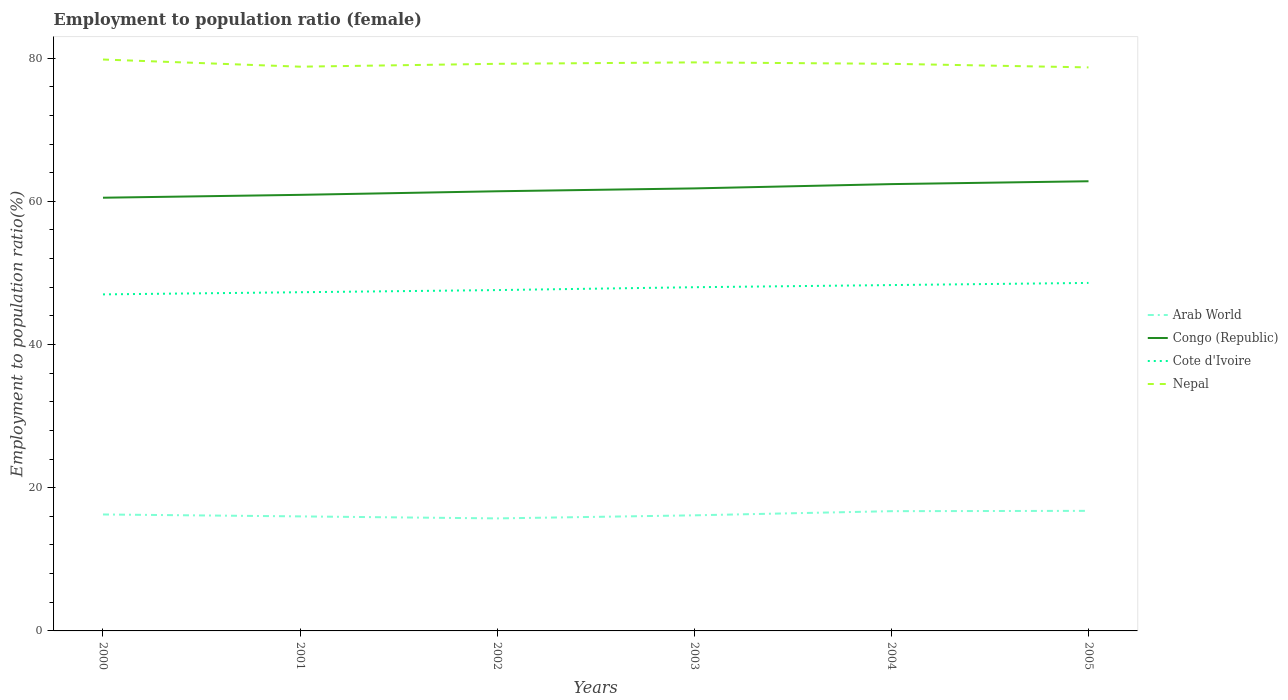How many different coloured lines are there?
Ensure brevity in your answer.  4. Is the number of lines equal to the number of legend labels?
Keep it short and to the point. Yes. In which year was the employment to population ratio in Nepal maximum?
Your answer should be very brief. 2005. What is the total employment to population ratio in Congo (Republic) in the graph?
Your answer should be compact. -1.9. What is the difference between the highest and the second highest employment to population ratio in Congo (Republic)?
Offer a terse response. 2.3. Is the employment to population ratio in Arab World strictly greater than the employment to population ratio in Nepal over the years?
Make the answer very short. Yes. How many years are there in the graph?
Your answer should be very brief. 6. Does the graph contain any zero values?
Make the answer very short. No. How many legend labels are there?
Your answer should be very brief. 4. How are the legend labels stacked?
Make the answer very short. Vertical. What is the title of the graph?
Keep it short and to the point. Employment to population ratio (female). What is the label or title of the X-axis?
Give a very brief answer. Years. What is the Employment to population ratio(%) in Arab World in 2000?
Provide a short and direct response. 16.26. What is the Employment to population ratio(%) in Congo (Republic) in 2000?
Offer a very short reply. 60.5. What is the Employment to population ratio(%) in Nepal in 2000?
Give a very brief answer. 79.8. What is the Employment to population ratio(%) in Arab World in 2001?
Your answer should be compact. 16. What is the Employment to population ratio(%) of Congo (Republic) in 2001?
Provide a short and direct response. 60.9. What is the Employment to population ratio(%) of Cote d'Ivoire in 2001?
Offer a very short reply. 47.3. What is the Employment to population ratio(%) of Nepal in 2001?
Offer a terse response. 78.8. What is the Employment to population ratio(%) of Arab World in 2002?
Ensure brevity in your answer.  15.71. What is the Employment to population ratio(%) of Congo (Republic) in 2002?
Make the answer very short. 61.4. What is the Employment to population ratio(%) in Cote d'Ivoire in 2002?
Your response must be concise. 47.6. What is the Employment to population ratio(%) in Nepal in 2002?
Give a very brief answer. 79.2. What is the Employment to population ratio(%) of Arab World in 2003?
Your answer should be compact. 16.14. What is the Employment to population ratio(%) in Congo (Republic) in 2003?
Your answer should be compact. 61.8. What is the Employment to population ratio(%) of Nepal in 2003?
Provide a short and direct response. 79.4. What is the Employment to population ratio(%) in Arab World in 2004?
Keep it short and to the point. 16.72. What is the Employment to population ratio(%) of Congo (Republic) in 2004?
Provide a succinct answer. 62.4. What is the Employment to population ratio(%) in Cote d'Ivoire in 2004?
Your response must be concise. 48.3. What is the Employment to population ratio(%) of Nepal in 2004?
Provide a short and direct response. 79.2. What is the Employment to population ratio(%) in Arab World in 2005?
Your response must be concise. 16.77. What is the Employment to population ratio(%) in Congo (Republic) in 2005?
Keep it short and to the point. 62.8. What is the Employment to population ratio(%) of Cote d'Ivoire in 2005?
Offer a terse response. 48.6. What is the Employment to population ratio(%) of Nepal in 2005?
Make the answer very short. 78.7. Across all years, what is the maximum Employment to population ratio(%) in Arab World?
Your answer should be very brief. 16.77. Across all years, what is the maximum Employment to population ratio(%) of Congo (Republic)?
Ensure brevity in your answer.  62.8. Across all years, what is the maximum Employment to population ratio(%) in Cote d'Ivoire?
Ensure brevity in your answer.  48.6. Across all years, what is the maximum Employment to population ratio(%) in Nepal?
Provide a short and direct response. 79.8. Across all years, what is the minimum Employment to population ratio(%) of Arab World?
Make the answer very short. 15.71. Across all years, what is the minimum Employment to population ratio(%) in Congo (Republic)?
Your answer should be compact. 60.5. Across all years, what is the minimum Employment to population ratio(%) in Nepal?
Keep it short and to the point. 78.7. What is the total Employment to population ratio(%) in Arab World in the graph?
Make the answer very short. 97.61. What is the total Employment to population ratio(%) in Congo (Republic) in the graph?
Give a very brief answer. 369.8. What is the total Employment to population ratio(%) in Cote d'Ivoire in the graph?
Offer a very short reply. 286.8. What is the total Employment to population ratio(%) in Nepal in the graph?
Your answer should be compact. 475.1. What is the difference between the Employment to population ratio(%) of Arab World in 2000 and that in 2001?
Your response must be concise. 0.27. What is the difference between the Employment to population ratio(%) in Nepal in 2000 and that in 2001?
Give a very brief answer. 1. What is the difference between the Employment to population ratio(%) in Arab World in 2000 and that in 2002?
Your answer should be compact. 0.55. What is the difference between the Employment to population ratio(%) of Cote d'Ivoire in 2000 and that in 2002?
Provide a short and direct response. -0.6. What is the difference between the Employment to population ratio(%) in Nepal in 2000 and that in 2002?
Offer a very short reply. 0.6. What is the difference between the Employment to population ratio(%) in Arab World in 2000 and that in 2003?
Your answer should be compact. 0.12. What is the difference between the Employment to population ratio(%) in Congo (Republic) in 2000 and that in 2003?
Provide a succinct answer. -1.3. What is the difference between the Employment to population ratio(%) of Nepal in 2000 and that in 2003?
Your answer should be very brief. 0.4. What is the difference between the Employment to population ratio(%) of Arab World in 2000 and that in 2004?
Offer a terse response. -0.46. What is the difference between the Employment to population ratio(%) of Congo (Republic) in 2000 and that in 2004?
Offer a very short reply. -1.9. What is the difference between the Employment to population ratio(%) in Arab World in 2000 and that in 2005?
Your answer should be compact. -0.5. What is the difference between the Employment to population ratio(%) in Congo (Republic) in 2000 and that in 2005?
Provide a short and direct response. -2.3. What is the difference between the Employment to population ratio(%) in Nepal in 2000 and that in 2005?
Offer a very short reply. 1.1. What is the difference between the Employment to population ratio(%) of Arab World in 2001 and that in 2002?
Your answer should be compact. 0.28. What is the difference between the Employment to population ratio(%) of Congo (Republic) in 2001 and that in 2002?
Keep it short and to the point. -0.5. What is the difference between the Employment to population ratio(%) in Cote d'Ivoire in 2001 and that in 2002?
Your answer should be compact. -0.3. What is the difference between the Employment to population ratio(%) in Nepal in 2001 and that in 2002?
Your response must be concise. -0.4. What is the difference between the Employment to population ratio(%) in Arab World in 2001 and that in 2003?
Your answer should be compact. -0.15. What is the difference between the Employment to population ratio(%) of Arab World in 2001 and that in 2004?
Provide a succinct answer. -0.73. What is the difference between the Employment to population ratio(%) in Arab World in 2001 and that in 2005?
Provide a short and direct response. -0.77. What is the difference between the Employment to population ratio(%) in Cote d'Ivoire in 2001 and that in 2005?
Make the answer very short. -1.3. What is the difference between the Employment to population ratio(%) of Nepal in 2001 and that in 2005?
Your response must be concise. 0.1. What is the difference between the Employment to population ratio(%) in Arab World in 2002 and that in 2003?
Offer a terse response. -0.43. What is the difference between the Employment to population ratio(%) of Congo (Republic) in 2002 and that in 2003?
Make the answer very short. -0.4. What is the difference between the Employment to population ratio(%) of Nepal in 2002 and that in 2003?
Keep it short and to the point. -0.2. What is the difference between the Employment to population ratio(%) in Arab World in 2002 and that in 2004?
Provide a short and direct response. -1.01. What is the difference between the Employment to population ratio(%) of Congo (Republic) in 2002 and that in 2004?
Your answer should be compact. -1. What is the difference between the Employment to population ratio(%) of Cote d'Ivoire in 2002 and that in 2004?
Ensure brevity in your answer.  -0.7. What is the difference between the Employment to population ratio(%) in Nepal in 2002 and that in 2004?
Keep it short and to the point. 0. What is the difference between the Employment to population ratio(%) of Arab World in 2002 and that in 2005?
Ensure brevity in your answer.  -1.05. What is the difference between the Employment to population ratio(%) in Arab World in 2003 and that in 2004?
Keep it short and to the point. -0.58. What is the difference between the Employment to population ratio(%) in Congo (Republic) in 2003 and that in 2004?
Your response must be concise. -0.6. What is the difference between the Employment to population ratio(%) of Arab World in 2003 and that in 2005?
Your answer should be compact. -0.62. What is the difference between the Employment to population ratio(%) of Congo (Republic) in 2003 and that in 2005?
Provide a succinct answer. -1. What is the difference between the Employment to population ratio(%) of Cote d'Ivoire in 2003 and that in 2005?
Your answer should be very brief. -0.6. What is the difference between the Employment to population ratio(%) in Arab World in 2004 and that in 2005?
Ensure brevity in your answer.  -0.04. What is the difference between the Employment to population ratio(%) in Cote d'Ivoire in 2004 and that in 2005?
Provide a succinct answer. -0.3. What is the difference between the Employment to population ratio(%) of Arab World in 2000 and the Employment to population ratio(%) of Congo (Republic) in 2001?
Your answer should be compact. -44.64. What is the difference between the Employment to population ratio(%) of Arab World in 2000 and the Employment to population ratio(%) of Cote d'Ivoire in 2001?
Offer a very short reply. -31.04. What is the difference between the Employment to population ratio(%) in Arab World in 2000 and the Employment to population ratio(%) in Nepal in 2001?
Make the answer very short. -62.54. What is the difference between the Employment to population ratio(%) of Congo (Republic) in 2000 and the Employment to population ratio(%) of Nepal in 2001?
Give a very brief answer. -18.3. What is the difference between the Employment to population ratio(%) of Cote d'Ivoire in 2000 and the Employment to population ratio(%) of Nepal in 2001?
Provide a succinct answer. -31.8. What is the difference between the Employment to population ratio(%) in Arab World in 2000 and the Employment to population ratio(%) in Congo (Republic) in 2002?
Make the answer very short. -45.14. What is the difference between the Employment to population ratio(%) of Arab World in 2000 and the Employment to population ratio(%) of Cote d'Ivoire in 2002?
Your answer should be compact. -31.34. What is the difference between the Employment to population ratio(%) in Arab World in 2000 and the Employment to population ratio(%) in Nepal in 2002?
Make the answer very short. -62.94. What is the difference between the Employment to population ratio(%) in Congo (Republic) in 2000 and the Employment to population ratio(%) in Nepal in 2002?
Offer a terse response. -18.7. What is the difference between the Employment to population ratio(%) of Cote d'Ivoire in 2000 and the Employment to population ratio(%) of Nepal in 2002?
Your answer should be compact. -32.2. What is the difference between the Employment to population ratio(%) of Arab World in 2000 and the Employment to population ratio(%) of Congo (Republic) in 2003?
Offer a very short reply. -45.54. What is the difference between the Employment to population ratio(%) in Arab World in 2000 and the Employment to population ratio(%) in Cote d'Ivoire in 2003?
Your answer should be very brief. -31.74. What is the difference between the Employment to population ratio(%) of Arab World in 2000 and the Employment to population ratio(%) of Nepal in 2003?
Your answer should be compact. -63.14. What is the difference between the Employment to population ratio(%) in Congo (Republic) in 2000 and the Employment to population ratio(%) in Nepal in 2003?
Ensure brevity in your answer.  -18.9. What is the difference between the Employment to population ratio(%) of Cote d'Ivoire in 2000 and the Employment to population ratio(%) of Nepal in 2003?
Keep it short and to the point. -32.4. What is the difference between the Employment to population ratio(%) in Arab World in 2000 and the Employment to population ratio(%) in Congo (Republic) in 2004?
Give a very brief answer. -46.14. What is the difference between the Employment to population ratio(%) of Arab World in 2000 and the Employment to population ratio(%) of Cote d'Ivoire in 2004?
Keep it short and to the point. -32.04. What is the difference between the Employment to population ratio(%) of Arab World in 2000 and the Employment to population ratio(%) of Nepal in 2004?
Your answer should be very brief. -62.94. What is the difference between the Employment to population ratio(%) of Congo (Republic) in 2000 and the Employment to population ratio(%) of Cote d'Ivoire in 2004?
Offer a very short reply. 12.2. What is the difference between the Employment to population ratio(%) in Congo (Republic) in 2000 and the Employment to population ratio(%) in Nepal in 2004?
Give a very brief answer. -18.7. What is the difference between the Employment to population ratio(%) of Cote d'Ivoire in 2000 and the Employment to population ratio(%) of Nepal in 2004?
Your answer should be very brief. -32.2. What is the difference between the Employment to population ratio(%) in Arab World in 2000 and the Employment to population ratio(%) in Congo (Republic) in 2005?
Your response must be concise. -46.54. What is the difference between the Employment to population ratio(%) of Arab World in 2000 and the Employment to population ratio(%) of Cote d'Ivoire in 2005?
Give a very brief answer. -32.34. What is the difference between the Employment to population ratio(%) in Arab World in 2000 and the Employment to population ratio(%) in Nepal in 2005?
Your answer should be compact. -62.44. What is the difference between the Employment to population ratio(%) of Congo (Republic) in 2000 and the Employment to population ratio(%) of Nepal in 2005?
Your answer should be compact. -18.2. What is the difference between the Employment to population ratio(%) in Cote d'Ivoire in 2000 and the Employment to population ratio(%) in Nepal in 2005?
Your answer should be very brief. -31.7. What is the difference between the Employment to population ratio(%) of Arab World in 2001 and the Employment to population ratio(%) of Congo (Republic) in 2002?
Provide a succinct answer. -45.4. What is the difference between the Employment to population ratio(%) in Arab World in 2001 and the Employment to population ratio(%) in Cote d'Ivoire in 2002?
Give a very brief answer. -31.6. What is the difference between the Employment to population ratio(%) of Arab World in 2001 and the Employment to population ratio(%) of Nepal in 2002?
Provide a succinct answer. -63.2. What is the difference between the Employment to population ratio(%) of Congo (Republic) in 2001 and the Employment to population ratio(%) of Nepal in 2002?
Provide a succinct answer. -18.3. What is the difference between the Employment to population ratio(%) in Cote d'Ivoire in 2001 and the Employment to population ratio(%) in Nepal in 2002?
Give a very brief answer. -31.9. What is the difference between the Employment to population ratio(%) in Arab World in 2001 and the Employment to population ratio(%) in Congo (Republic) in 2003?
Offer a terse response. -45.8. What is the difference between the Employment to population ratio(%) of Arab World in 2001 and the Employment to population ratio(%) of Cote d'Ivoire in 2003?
Your response must be concise. -32. What is the difference between the Employment to population ratio(%) of Arab World in 2001 and the Employment to population ratio(%) of Nepal in 2003?
Provide a short and direct response. -63.4. What is the difference between the Employment to population ratio(%) in Congo (Republic) in 2001 and the Employment to population ratio(%) in Nepal in 2003?
Your answer should be very brief. -18.5. What is the difference between the Employment to population ratio(%) in Cote d'Ivoire in 2001 and the Employment to population ratio(%) in Nepal in 2003?
Ensure brevity in your answer.  -32.1. What is the difference between the Employment to population ratio(%) of Arab World in 2001 and the Employment to population ratio(%) of Congo (Republic) in 2004?
Provide a short and direct response. -46.4. What is the difference between the Employment to population ratio(%) in Arab World in 2001 and the Employment to population ratio(%) in Cote d'Ivoire in 2004?
Ensure brevity in your answer.  -32.3. What is the difference between the Employment to population ratio(%) of Arab World in 2001 and the Employment to population ratio(%) of Nepal in 2004?
Your response must be concise. -63.2. What is the difference between the Employment to population ratio(%) of Congo (Republic) in 2001 and the Employment to population ratio(%) of Cote d'Ivoire in 2004?
Ensure brevity in your answer.  12.6. What is the difference between the Employment to population ratio(%) of Congo (Republic) in 2001 and the Employment to population ratio(%) of Nepal in 2004?
Your answer should be compact. -18.3. What is the difference between the Employment to population ratio(%) of Cote d'Ivoire in 2001 and the Employment to population ratio(%) of Nepal in 2004?
Give a very brief answer. -31.9. What is the difference between the Employment to population ratio(%) in Arab World in 2001 and the Employment to population ratio(%) in Congo (Republic) in 2005?
Make the answer very short. -46.8. What is the difference between the Employment to population ratio(%) in Arab World in 2001 and the Employment to population ratio(%) in Cote d'Ivoire in 2005?
Provide a short and direct response. -32.6. What is the difference between the Employment to population ratio(%) of Arab World in 2001 and the Employment to population ratio(%) of Nepal in 2005?
Offer a very short reply. -62.7. What is the difference between the Employment to population ratio(%) in Congo (Republic) in 2001 and the Employment to population ratio(%) in Nepal in 2005?
Your answer should be compact. -17.8. What is the difference between the Employment to population ratio(%) of Cote d'Ivoire in 2001 and the Employment to population ratio(%) of Nepal in 2005?
Provide a short and direct response. -31.4. What is the difference between the Employment to population ratio(%) of Arab World in 2002 and the Employment to population ratio(%) of Congo (Republic) in 2003?
Your answer should be very brief. -46.09. What is the difference between the Employment to population ratio(%) in Arab World in 2002 and the Employment to population ratio(%) in Cote d'Ivoire in 2003?
Give a very brief answer. -32.29. What is the difference between the Employment to population ratio(%) of Arab World in 2002 and the Employment to population ratio(%) of Nepal in 2003?
Provide a succinct answer. -63.69. What is the difference between the Employment to population ratio(%) in Congo (Republic) in 2002 and the Employment to population ratio(%) in Nepal in 2003?
Your answer should be compact. -18. What is the difference between the Employment to population ratio(%) of Cote d'Ivoire in 2002 and the Employment to population ratio(%) of Nepal in 2003?
Offer a very short reply. -31.8. What is the difference between the Employment to population ratio(%) of Arab World in 2002 and the Employment to population ratio(%) of Congo (Republic) in 2004?
Offer a very short reply. -46.69. What is the difference between the Employment to population ratio(%) of Arab World in 2002 and the Employment to population ratio(%) of Cote d'Ivoire in 2004?
Ensure brevity in your answer.  -32.59. What is the difference between the Employment to population ratio(%) of Arab World in 2002 and the Employment to population ratio(%) of Nepal in 2004?
Ensure brevity in your answer.  -63.49. What is the difference between the Employment to population ratio(%) in Congo (Republic) in 2002 and the Employment to population ratio(%) in Cote d'Ivoire in 2004?
Your answer should be compact. 13.1. What is the difference between the Employment to population ratio(%) in Congo (Republic) in 2002 and the Employment to population ratio(%) in Nepal in 2004?
Your response must be concise. -17.8. What is the difference between the Employment to population ratio(%) of Cote d'Ivoire in 2002 and the Employment to population ratio(%) of Nepal in 2004?
Offer a very short reply. -31.6. What is the difference between the Employment to population ratio(%) in Arab World in 2002 and the Employment to population ratio(%) in Congo (Republic) in 2005?
Offer a terse response. -47.09. What is the difference between the Employment to population ratio(%) in Arab World in 2002 and the Employment to population ratio(%) in Cote d'Ivoire in 2005?
Offer a terse response. -32.89. What is the difference between the Employment to population ratio(%) in Arab World in 2002 and the Employment to population ratio(%) in Nepal in 2005?
Make the answer very short. -62.99. What is the difference between the Employment to population ratio(%) in Congo (Republic) in 2002 and the Employment to population ratio(%) in Nepal in 2005?
Provide a succinct answer. -17.3. What is the difference between the Employment to population ratio(%) in Cote d'Ivoire in 2002 and the Employment to population ratio(%) in Nepal in 2005?
Provide a succinct answer. -31.1. What is the difference between the Employment to population ratio(%) of Arab World in 2003 and the Employment to population ratio(%) of Congo (Republic) in 2004?
Offer a terse response. -46.26. What is the difference between the Employment to population ratio(%) of Arab World in 2003 and the Employment to population ratio(%) of Cote d'Ivoire in 2004?
Your answer should be very brief. -32.16. What is the difference between the Employment to population ratio(%) in Arab World in 2003 and the Employment to population ratio(%) in Nepal in 2004?
Offer a terse response. -63.06. What is the difference between the Employment to population ratio(%) of Congo (Republic) in 2003 and the Employment to population ratio(%) of Cote d'Ivoire in 2004?
Give a very brief answer. 13.5. What is the difference between the Employment to population ratio(%) in Congo (Republic) in 2003 and the Employment to population ratio(%) in Nepal in 2004?
Your response must be concise. -17.4. What is the difference between the Employment to population ratio(%) of Cote d'Ivoire in 2003 and the Employment to population ratio(%) of Nepal in 2004?
Keep it short and to the point. -31.2. What is the difference between the Employment to population ratio(%) of Arab World in 2003 and the Employment to population ratio(%) of Congo (Republic) in 2005?
Your response must be concise. -46.66. What is the difference between the Employment to population ratio(%) in Arab World in 2003 and the Employment to population ratio(%) in Cote d'Ivoire in 2005?
Offer a very short reply. -32.46. What is the difference between the Employment to population ratio(%) of Arab World in 2003 and the Employment to population ratio(%) of Nepal in 2005?
Your answer should be very brief. -62.56. What is the difference between the Employment to population ratio(%) of Congo (Republic) in 2003 and the Employment to population ratio(%) of Nepal in 2005?
Offer a terse response. -16.9. What is the difference between the Employment to population ratio(%) in Cote d'Ivoire in 2003 and the Employment to population ratio(%) in Nepal in 2005?
Provide a short and direct response. -30.7. What is the difference between the Employment to population ratio(%) in Arab World in 2004 and the Employment to population ratio(%) in Congo (Republic) in 2005?
Your answer should be very brief. -46.08. What is the difference between the Employment to population ratio(%) of Arab World in 2004 and the Employment to population ratio(%) of Cote d'Ivoire in 2005?
Offer a terse response. -31.88. What is the difference between the Employment to population ratio(%) in Arab World in 2004 and the Employment to population ratio(%) in Nepal in 2005?
Ensure brevity in your answer.  -61.98. What is the difference between the Employment to population ratio(%) in Congo (Republic) in 2004 and the Employment to population ratio(%) in Nepal in 2005?
Offer a terse response. -16.3. What is the difference between the Employment to population ratio(%) in Cote d'Ivoire in 2004 and the Employment to population ratio(%) in Nepal in 2005?
Ensure brevity in your answer.  -30.4. What is the average Employment to population ratio(%) in Arab World per year?
Offer a very short reply. 16.27. What is the average Employment to population ratio(%) of Congo (Republic) per year?
Your answer should be compact. 61.63. What is the average Employment to population ratio(%) in Cote d'Ivoire per year?
Give a very brief answer. 47.8. What is the average Employment to population ratio(%) of Nepal per year?
Your answer should be very brief. 79.18. In the year 2000, what is the difference between the Employment to population ratio(%) of Arab World and Employment to population ratio(%) of Congo (Republic)?
Ensure brevity in your answer.  -44.24. In the year 2000, what is the difference between the Employment to population ratio(%) of Arab World and Employment to population ratio(%) of Cote d'Ivoire?
Give a very brief answer. -30.74. In the year 2000, what is the difference between the Employment to population ratio(%) in Arab World and Employment to population ratio(%) in Nepal?
Your answer should be very brief. -63.54. In the year 2000, what is the difference between the Employment to population ratio(%) of Congo (Republic) and Employment to population ratio(%) of Cote d'Ivoire?
Your response must be concise. 13.5. In the year 2000, what is the difference between the Employment to population ratio(%) in Congo (Republic) and Employment to population ratio(%) in Nepal?
Ensure brevity in your answer.  -19.3. In the year 2000, what is the difference between the Employment to population ratio(%) in Cote d'Ivoire and Employment to population ratio(%) in Nepal?
Your answer should be compact. -32.8. In the year 2001, what is the difference between the Employment to population ratio(%) in Arab World and Employment to population ratio(%) in Congo (Republic)?
Your answer should be very brief. -44.9. In the year 2001, what is the difference between the Employment to population ratio(%) of Arab World and Employment to population ratio(%) of Cote d'Ivoire?
Provide a succinct answer. -31.3. In the year 2001, what is the difference between the Employment to population ratio(%) of Arab World and Employment to population ratio(%) of Nepal?
Ensure brevity in your answer.  -62.8. In the year 2001, what is the difference between the Employment to population ratio(%) in Congo (Republic) and Employment to population ratio(%) in Cote d'Ivoire?
Provide a short and direct response. 13.6. In the year 2001, what is the difference between the Employment to population ratio(%) in Congo (Republic) and Employment to population ratio(%) in Nepal?
Ensure brevity in your answer.  -17.9. In the year 2001, what is the difference between the Employment to population ratio(%) in Cote d'Ivoire and Employment to population ratio(%) in Nepal?
Offer a very short reply. -31.5. In the year 2002, what is the difference between the Employment to population ratio(%) in Arab World and Employment to population ratio(%) in Congo (Republic)?
Give a very brief answer. -45.69. In the year 2002, what is the difference between the Employment to population ratio(%) in Arab World and Employment to population ratio(%) in Cote d'Ivoire?
Provide a succinct answer. -31.89. In the year 2002, what is the difference between the Employment to population ratio(%) in Arab World and Employment to population ratio(%) in Nepal?
Provide a short and direct response. -63.49. In the year 2002, what is the difference between the Employment to population ratio(%) in Congo (Republic) and Employment to population ratio(%) in Cote d'Ivoire?
Give a very brief answer. 13.8. In the year 2002, what is the difference between the Employment to population ratio(%) of Congo (Republic) and Employment to population ratio(%) of Nepal?
Offer a terse response. -17.8. In the year 2002, what is the difference between the Employment to population ratio(%) of Cote d'Ivoire and Employment to population ratio(%) of Nepal?
Provide a short and direct response. -31.6. In the year 2003, what is the difference between the Employment to population ratio(%) of Arab World and Employment to population ratio(%) of Congo (Republic)?
Offer a very short reply. -45.66. In the year 2003, what is the difference between the Employment to population ratio(%) of Arab World and Employment to population ratio(%) of Cote d'Ivoire?
Make the answer very short. -31.86. In the year 2003, what is the difference between the Employment to population ratio(%) in Arab World and Employment to population ratio(%) in Nepal?
Provide a succinct answer. -63.26. In the year 2003, what is the difference between the Employment to population ratio(%) of Congo (Republic) and Employment to population ratio(%) of Nepal?
Offer a terse response. -17.6. In the year 2003, what is the difference between the Employment to population ratio(%) of Cote d'Ivoire and Employment to population ratio(%) of Nepal?
Your response must be concise. -31.4. In the year 2004, what is the difference between the Employment to population ratio(%) of Arab World and Employment to population ratio(%) of Congo (Republic)?
Make the answer very short. -45.68. In the year 2004, what is the difference between the Employment to population ratio(%) of Arab World and Employment to population ratio(%) of Cote d'Ivoire?
Your answer should be very brief. -31.58. In the year 2004, what is the difference between the Employment to population ratio(%) in Arab World and Employment to population ratio(%) in Nepal?
Provide a succinct answer. -62.48. In the year 2004, what is the difference between the Employment to population ratio(%) of Congo (Republic) and Employment to population ratio(%) of Nepal?
Provide a succinct answer. -16.8. In the year 2004, what is the difference between the Employment to population ratio(%) in Cote d'Ivoire and Employment to population ratio(%) in Nepal?
Provide a succinct answer. -30.9. In the year 2005, what is the difference between the Employment to population ratio(%) of Arab World and Employment to population ratio(%) of Congo (Republic)?
Keep it short and to the point. -46.03. In the year 2005, what is the difference between the Employment to population ratio(%) of Arab World and Employment to population ratio(%) of Cote d'Ivoire?
Give a very brief answer. -31.83. In the year 2005, what is the difference between the Employment to population ratio(%) in Arab World and Employment to population ratio(%) in Nepal?
Your response must be concise. -61.93. In the year 2005, what is the difference between the Employment to population ratio(%) of Congo (Republic) and Employment to population ratio(%) of Cote d'Ivoire?
Your answer should be very brief. 14.2. In the year 2005, what is the difference between the Employment to population ratio(%) of Congo (Republic) and Employment to population ratio(%) of Nepal?
Your answer should be compact. -15.9. In the year 2005, what is the difference between the Employment to population ratio(%) in Cote d'Ivoire and Employment to population ratio(%) in Nepal?
Your answer should be compact. -30.1. What is the ratio of the Employment to population ratio(%) in Arab World in 2000 to that in 2001?
Make the answer very short. 1.02. What is the ratio of the Employment to population ratio(%) in Congo (Republic) in 2000 to that in 2001?
Provide a short and direct response. 0.99. What is the ratio of the Employment to population ratio(%) in Cote d'Ivoire in 2000 to that in 2001?
Your answer should be very brief. 0.99. What is the ratio of the Employment to population ratio(%) of Nepal in 2000 to that in 2001?
Make the answer very short. 1.01. What is the ratio of the Employment to population ratio(%) of Arab World in 2000 to that in 2002?
Offer a terse response. 1.03. What is the ratio of the Employment to population ratio(%) in Congo (Republic) in 2000 to that in 2002?
Offer a terse response. 0.99. What is the ratio of the Employment to population ratio(%) of Cote d'Ivoire in 2000 to that in 2002?
Give a very brief answer. 0.99. What is the ratio of the Employment to population ratio(%) in Nepal in 2000 to that in 2002?
Make the answer very short. 1.01. What is the ratio of the Employment to population ratio(%) of Arab World in 2000 to that in 2003?
Keep it short and to the point. 1.01. What is the ratio of the Employment to population ratio(%) of Congo (Republic) in 2000 to that in 2003?
Your response must be concise. 0.98. What is the ratio of the Employment to population ratio(%) in Cote d'Ivoire in 2000 to that in 2003?
Provide a succinct answer. 0.98. What is the ratio of the Employment to population ratio(%) in Nepal in 2000 to that in 2003?
Ensure brevity in your answer.  1. What is the ratio of the Employment to population ratio(%) of Arab World in 2000 to that in 2004?
Provide a succinct answer. 0.97. What is the ratio of the Employment to population ratio(%) in Congo (Republic) in 2000 to that in 2004?
Keep it short and to the point. 0.97. What is the ratio of the Employment to population ratio(%) of Cote d'Ivoire in 2000 to that in 2004?
Your response must be concise. 0.97. What is the ratio of the Employment to population ratio(%) in Nepal in 2000 to that in 2004?
Provide a short and direct response. 1.01. What is the ratio of the Employment to population ratio(%) in Arab World in 2000 to that in 2005?
Your answer should be very brief. 0.97. What is the ratio of the Employment to population ratio(%) of Congo (Republic) in 2000 to that in 2005?
Make the answer very short. 0.96. What is the ratio of the Employment to population ratio(%) in Cote d'Ivoire in 2000 to that in 2005?
Your response must be concise. 0.97. What is the ratio of the Employment to population ratio(%) in Arab World in 2001 to that in 2002?
Offer a very short reply. 1.02. What is the ratio of the Employment to population ratio(%) in Nepal in 2001 to that in 2002?
Your response must be concise. 0.99. What is the ratio of the Employment to population ratio(%) in Arab World in 2001 to that in 2003?
Keep it short and to the point. 0.99. What is the ratio of the Employment to population ratio(%) in Congo (Republic) in 2001 to that in 2003?
Your response must be concise. 0.99. What is the ratio of the Employment to population ratio(%) in Cote d'Ivoire in 2001 to that in 2003?
Give a very brief answer. 0.99. What is the ratio of the Employment to population ratio(%) in Nepal in 2001 to that in 2003?
Ensure brevity in your answer.  0.99. What is the ratio of the Employment to population ratio(%) in Arab World in 2001 to that in 2004?
Keep it short and to the point. 0.96. What is the ratio of the Employment to population ratio(%) of Congo (Republic) in 2001 to that in 2004?
Your answer should be very brief. 0.98. What is the ratio of the Employment to population ratio(%) in Cote d'Ivoire in 2001 to that in 2004?
Provide a succinct answer. 0.98. What is the ratio of the Employment to population ratio(%) in Nepal in 2001 to that in 2004?
Your answer should be compact. 0.99. What is the ratio of the Employment to population ratio(%) of Arab World in 2001 to that in 2005?
Provide a short and direct response. 0.95. What is the ratio of the Employment to population ratio(%) of Congo (Republic) in 2001 to that in 2005?
Your response must be concise. 0.97. What is the ratio of the Employment to population ratio(%) in Cote d'Ivoire in 2001 to that in 2005?
Give a very brief answer. 0.97. What is the ratio of the Employment to population ratio(%) in Arab World in 2002 to that in 2003?
Keep it short and to the point. 0.97. What is the ratio of the Employment to population ratio(%) of Congo (Republic) in 2002 to that in 2003?
Your answer should be compact. 0.99. What is the ratio of the Employment to population ratio(%) in Nepal in 2002 to that in 2003?
Offer a terse response. 1. What is the ratio of the Employment to population ratio(%) of Arab World in 2002 to that in 2004?
Give a very brief answer. 0.94. What is the ratio of the Employment to population ratio(%) in Congo (Republic) in 2002 to that in 2004?
Your answer should be very brief. 0.98. What is the ratio of the Employment to population ratio(%) in Cote d'Ivoire in 2002 to that in 2004?
Offer a very short reply. 0.99. What is the ratio of the Employment to population ratio(%) of Nepal in 2002 to that in 2004?
Provide a succinct answer. 1. What is the ratio of the Employment to population ratio(%) of Arab World in 2002 to that in 2005?
Provide a short and direct response. 0.94. What is the ratio of the Employment to population ratio(%) of Congo (Republic) in 2002 to that in 2005?
Your response must be concise. 0.98. What is the ratio of the Employment to population ratio(%) of Cote d'Ivoire in 2002 to that in 2005?
Give a very brief answer. 0.98. What is the ratio of the Employment to population ratio(%) in Nepal in 2002 to that in 2005?
Offer a very short reply. 1.01. What is the ratio of the Employment to population ratio(%) in Arab World in 2003 to that in 2004?
Your answer should be compact. 0.97. What is the ratio of the Employment to population ratio(%) in Cote d'Ivoire in 2003 to that in 2004?
Your answer should be very brief. 0.99. What is the ratio of the Employment to population ratio(%) in Arab World in 2003 to that in 2005?
Your answer should be compact. 0.96. What is the ratio of the Employment to population ratio(%) of Congo (Republic) in 2003 to that in 2005?
Your answer should be compact. 0.98. What is the ratio of the Employment to population ratio(%) in Cote d'Ivoire in 2003 to that in 2005?
Give a very brief answer. 0.99. What is the ratio of the Employment to population ratio(%) in Nepal in 2003 to that in 2005?
Ensure brevity in your answer.  1.01. What is the ratio of the Employment to population ratio(%) of Arab World in 2004 to that in 2005?
Keep it short and to the point. 1. What is the ratio of the Employment to population ratio(%) in Congo (Republic) in 2004 to that in 2005?
Offer a very short reply. 0.99. What is the ratio of the Employment to population ratio(%) of Cote d'Ivoire in 2004 to that in 2005?
Your answer should be compact. 0.99. What is the ratio of the Employment to population ratio(%) in Nepal in 2004 to that in 2005?
Offer a terse response. 1.01. What is the difference between the highest and the second highest Employment to population ratio(%) in Arab World?
Make the answer very short. 0.04. What is the difference between the highest and the second highest Employment to population ratio(%) of Congo (Republic)?
Give a very brief answer. 0.4. What is the difference between the highest and the second highest Employment to population ratio(%) in Cote d'Ivoire?
Your response must be concise. 0.3. What is the difference between the highest and the lowest Employment to population ratio(%) of Arab World?
Your answer should be compact. 1.05. What is the difference between the highest and the lowest Employment to population ratio(%) of Congo (Republic)?
Your answer should be very brief. 2.3. What is the difference between the highest and the lowest Employment to population ratio(%) in Nepal?
Provide a short and direct response. 1.1. 